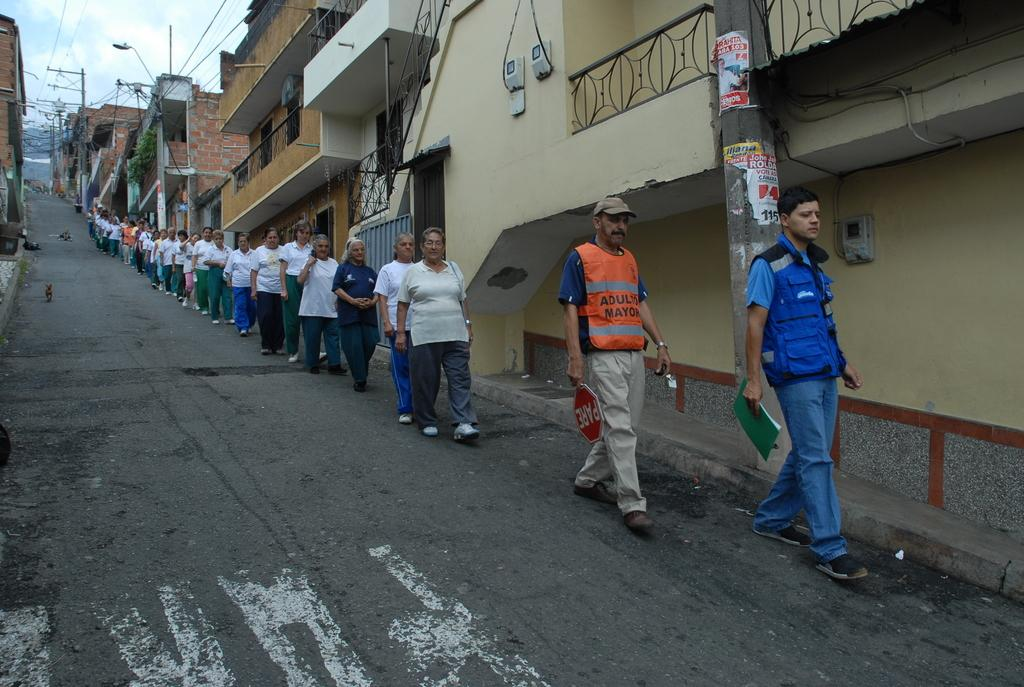How many people are in the image? There is a group of people in the image, but the exact number is not specified. What are the people in the image doing? The people are walking on the road in the image. What other living creature is present in the image? There is a dog in the image. What objects can be seen in the image besides the people and the dog? There is a book, a board, buildings, and poles in the image. What can be seen in the background of the image? The sky is visible in the background of the image. How does the dog use its tongue to perform a trick in the image? There is no trick being performed by the dog in the image, and the dog's tongue is not mentioned. 